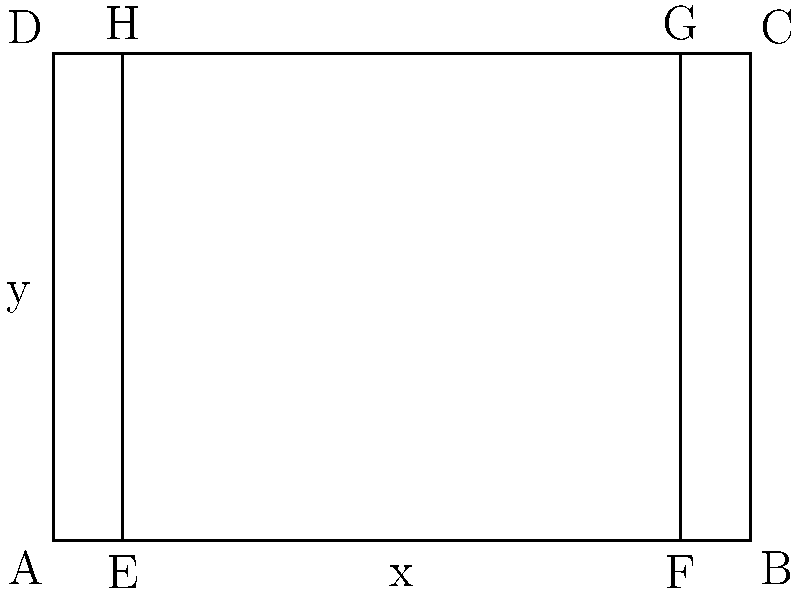Unathi Mali is designing a new rugby field for a local club. The field is represented by a rectangle ABCD, with an inner playing area EFGH. Given that the equations of the boundary lines are:

AB: $y = 0$
BC: $x = 100$
CD: $y = 70$
DA: $x = 0$
EF: $y = 10$
FG: $x = 90$
GH: $y = 60$
HE: $x = 10$

Calculate the area of the entire field (ABCD) and the area of the sidelines (the region between ABCD and EFGH). Let's approach this step-by-step:

1) Area of the entire field (ABCD):
   - Width = x-coordinate of B - x-coordinate of A = 100 - 0 = 100 meters
   - Length = y-coordinate of D - y-coordinate of A = 70 - 0 = 70 meters
   - Area of ABCD = $100 * 70 = 7000$ square meters

2) Area of the inner playing field (EFGH):
   - Width = x-coordinate of F - x-coordinate of E = 90 - 10 = 80 meters
   - Length = y-coordinate of H - y-coordinate of E = 60 - 10 = 50 meters
   - Area of EFGH = $80 * 50 = 4000$ square meters

3) Area of the sidelines:
   - This is the difference between the area of ABCD and EFGH
   - Area of sidelines = Area of ABCD - Area of EFGH
   - Area of sidelines = $7000 - 4000 = 3000$ square meters

Therefore, the area of the entire field is 7000 square meters, and the area of the sidelines is 3000 square meters.
Answer: Entire field: 7000 m², Sidelines: 3000 m² 